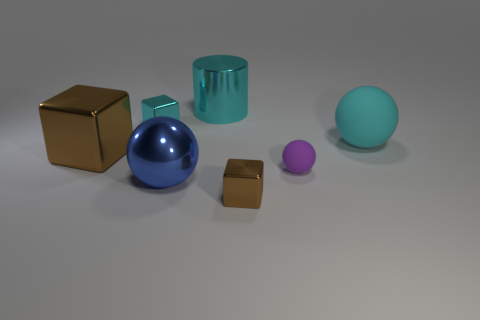Subtract all tiny cyan blocks. How many blocks are left? 2 Subtract 1 cylinders. How many cylinders are left? 0 Add 2 cyan metallic objects. How many objects exist? 9 Subtract all cylinders. How many objects are left? 6 Subtract all cyan cubes. How many cubes are left? 2 Subtract 0 brown balls. How many objects are left? 7 Subtract all gray blocks. Subtract all yellow cylinders. How many blocks are left? 3 Subtract all cyan cubes. How many cyan spheres are left? 1 Subtract all large cylinders. Subtract all brown cubes. How many objects are left? 4 Add 3 big spheres. How many big spheres are left? 5 